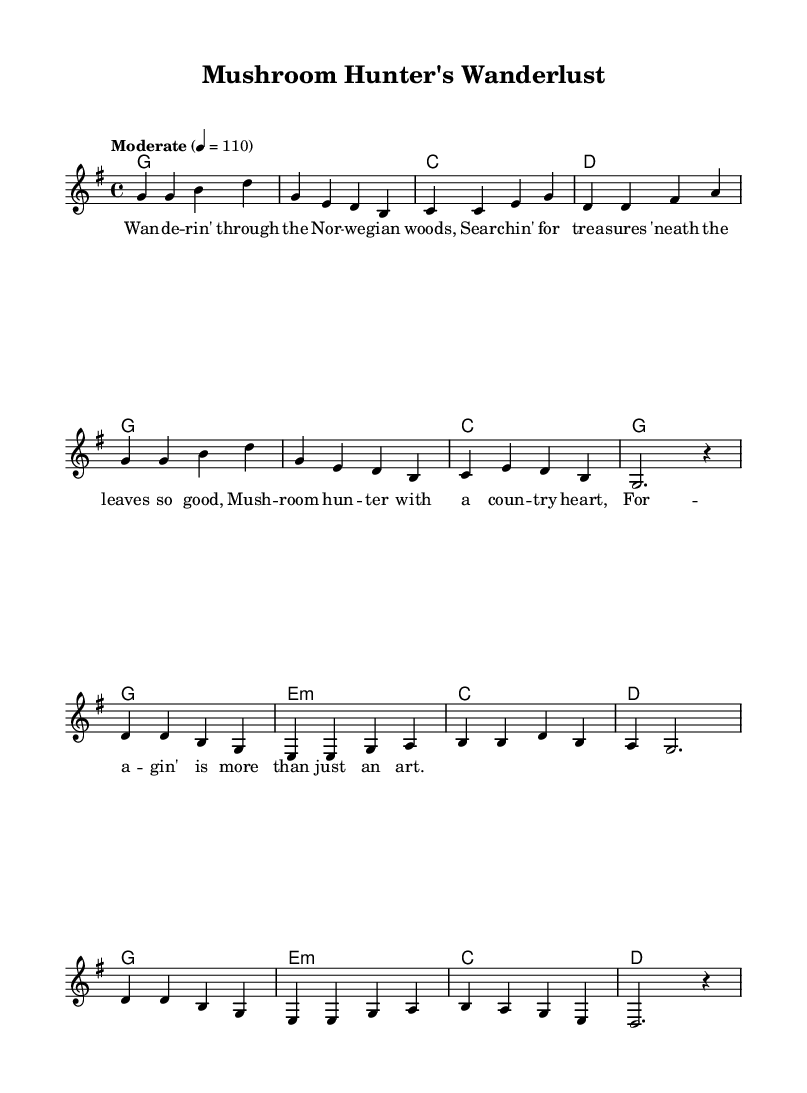What is the key signature of this music? The key signature indicated is G major, which has one sharp (F#). This can be identified at the beginning of the staff where the key signature is shown.
Answer: G major What is the time signature of this piece? The time signature at the beginning of the music is 4/4, which means there are four beats in each measure and the quarter note gets one beat. This can be found right after the key signature.
Answer: 4/4 What is the tempo marking given for this piece? The tempo marking states "Moderate" with a metronome marking of 110 beats per minute. This informs the performer of the speed at which to play. It is typically found above the staff in the score.
Answer: Moderate 4 = 110 How many measures are in the verse section? The verse section contains eight measures, which can be counted from the melody part where the measures are visually divided by vertical lines.
Answer: Eight What chord follows the first measure of the chorus? The first measure of the chorus shows a G major chord, which can be determined by looking at the chord names specified in the chord section at the beginning of the chorus.
Answer: G What is the lyrical theme of this piece? The theme revolves around foraging in the wilderness, as suggested by the lyrics that talk about wandering in the Norwegian woods and searching for treasures. This can be inferred from the words written under the melody.
Answer: Foraging What is the last note of the melody? The last note of the melody is a G, verified from the melody part where the notes are laid out in sequence. The music concludes with a G after the rests in the last measure.
Answer: G 